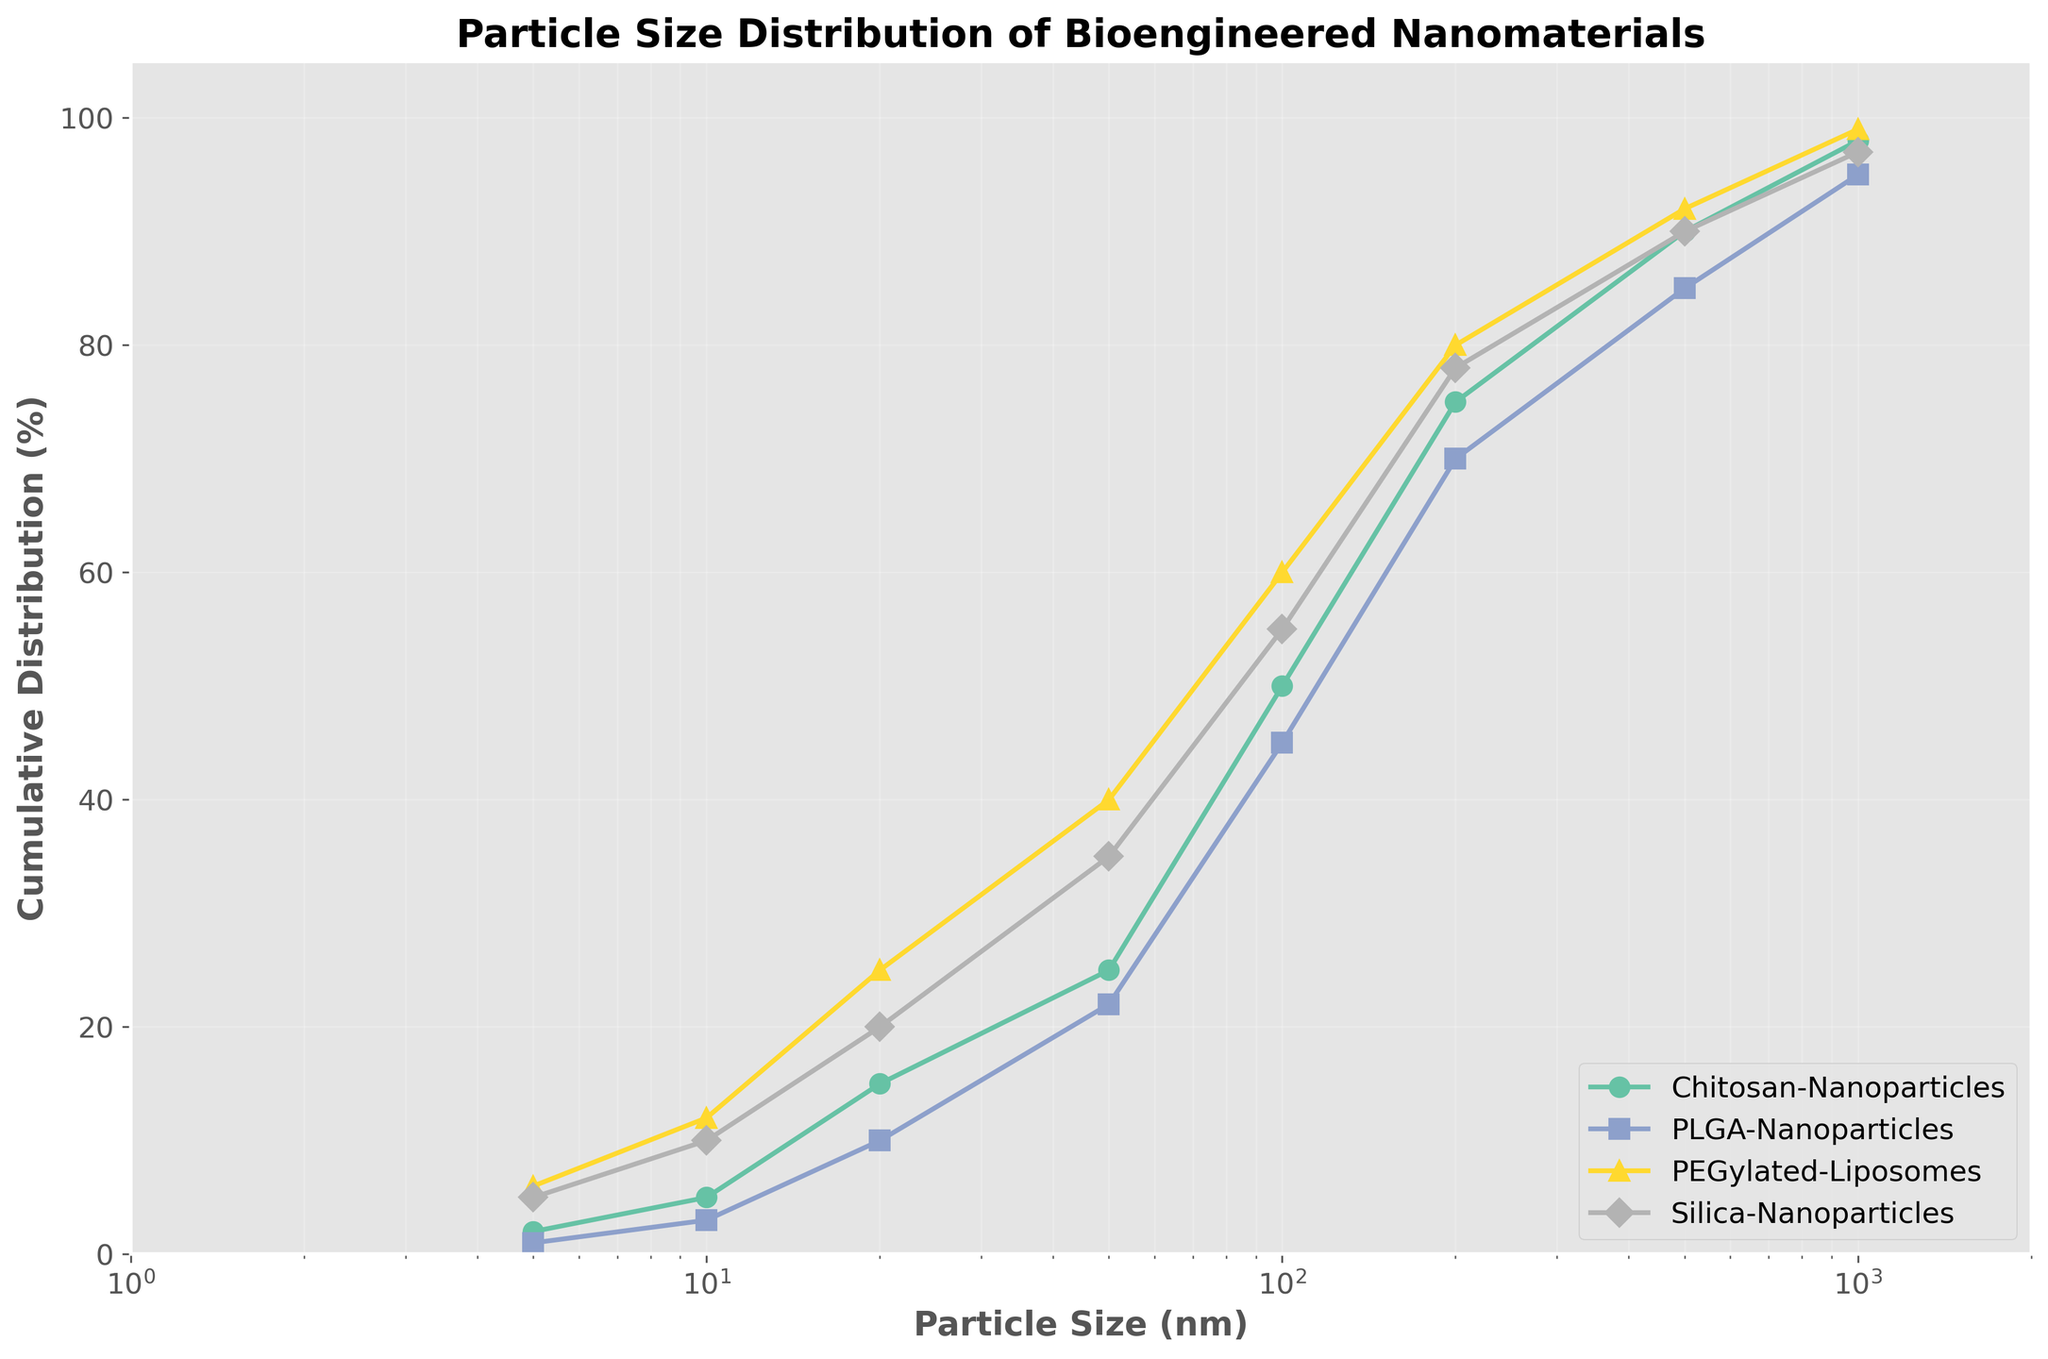What is the title of the figure? The title is typically found at the top of the figure and helps describe what the visual represents.
Answer: Particle Size Distribution of Bioengineered Nanomaterials What is the x-axis label in the figure? The x-axis label describes the parameter along the horizontal axis of the graph.
Answer: Particle Size (nm) Which material has the highest cumulative distribution percentage for a particle size of 5 nm? Look at the data points for a particle size of 5 nm and identify the material with the highest cumulative distribution percentage.
Answer: PEGylated-Liposomes How does the cumulative distribution percentage for PLGA-Nanoparticles at 100 nm compare to that of Chitosan-Nanoparticles at the same size? Compare the cumulative distribution percentages on the curve for PLGA-Nanoparticles and Chitosan-Nanoparticles at the 100 nm particle size mark.
Answer: PLGA-Nanoparticles have a lower cumulative distribution percentage (45% vs 50%) What particle size corresponds to a cumulative distribution percentage of 90% for Silica-Nanoparticles? Identify the particle size on the Silica-Nanoparticles curve where the cumulative distribution percentage is 90%.
Answer: 500 nm What is the color used for representing Chitosan-Nanoparticles in the plot? Determine the color assigned to the Chitosan-Nanoparticles series from the legend.
Answer: Color corresponding to Chitosan-Nanoparticles in the Set2 colormap Which material reaches a cumulative distribution percentage of 70% for the smallest particle size? Identify the material that first reaches 70% for the smallest particle size value from the plot lines.
Answer: PLGA-Nanoparticles at 200 nm Compare the cumulative distribution percentages of PEGylated-Liposomes and Silica-Nanoparticles at a particle size of 20 nm. Locate the respective cumulative distribution percentages for PEGylated-Liposomes and Silica-Nanoparticles at the 20 nm particle size.
Answer: PEGylated-Liposomes have a higher percentage (25% vs 20%) How many materials have reached or exceeded a cumulative distribution percentage of 50% by the particle size of 100 nm? Count the number of materials whose curves have reached or passed the 50% cumulative distribution by the 100 nm mark.
Answer: Three materials (Chitosan-Nanoparticles, PEGylated-Liposomes, Silica-Nanoparticles) At what particle size does Chitosan-Nanoparticles reach a cumulative distribution percentage of 75%? Identify on the graph at which particle size the Chitosan-Nanoparticles line intersects the 75% cumulative distribution level.
Answer: 200 nm 